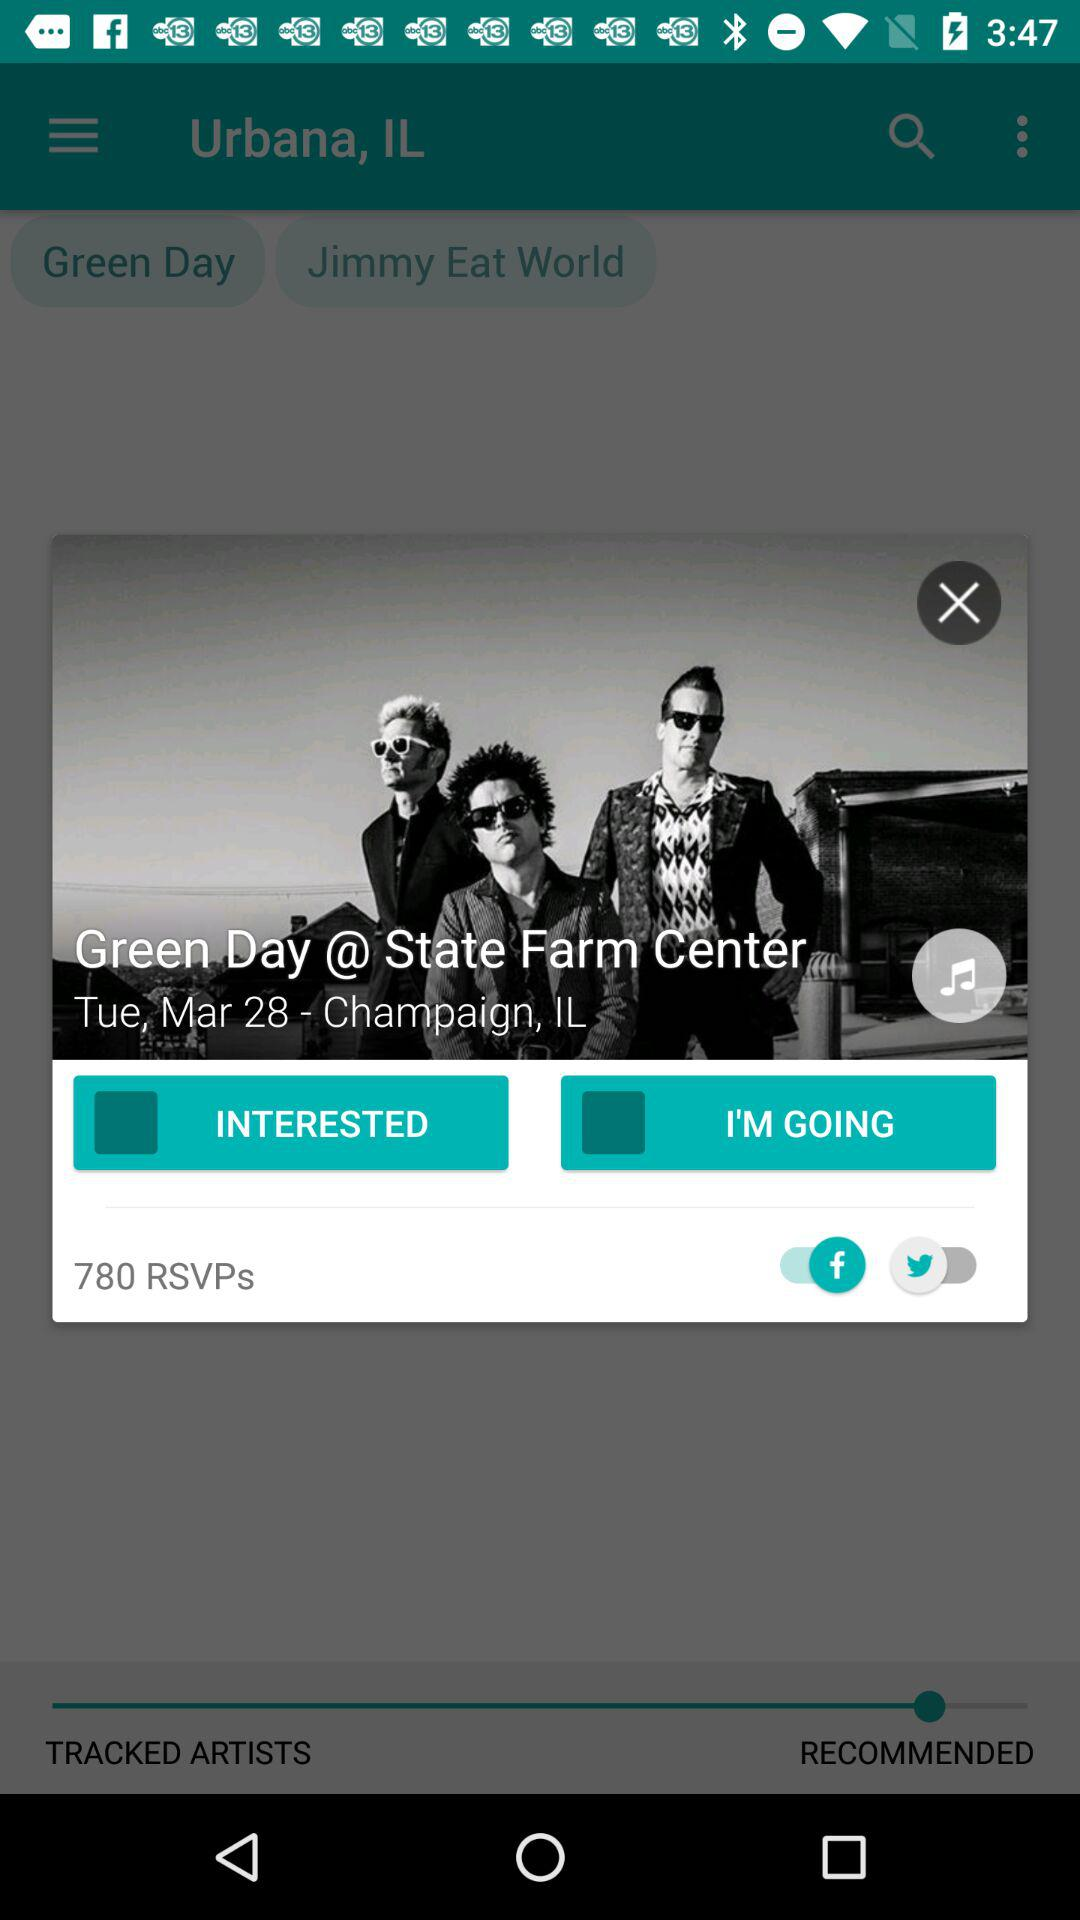What is the song name?
When the provided information is insufficient, respond with <no answer>. <no answer> 